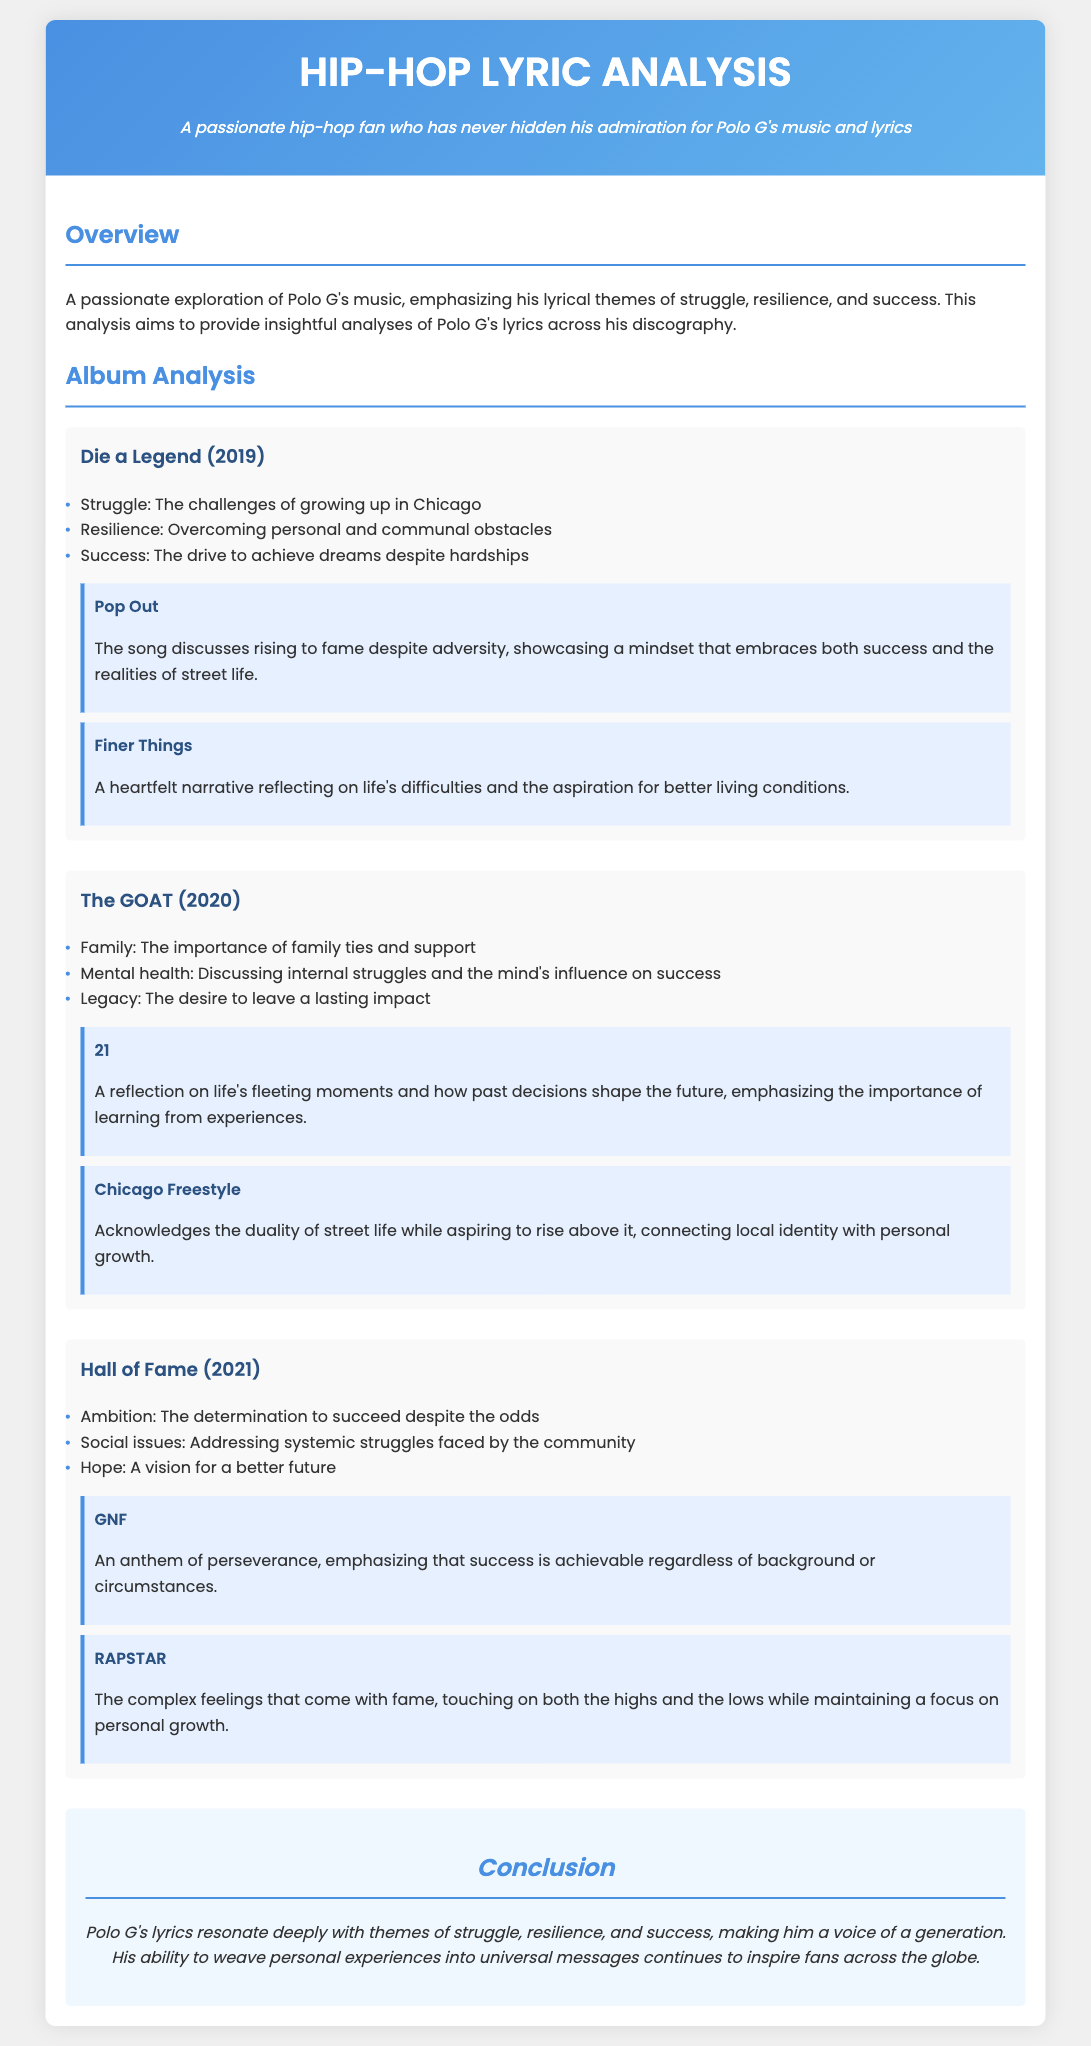What is the title of the resume? The title is prominently displayed at the top of the document, stating the focus on lyrical analysis of Polo G's work.
Answer: Hip-Hop Lyric Analysis What year was the album "Die a Legend" released? The album's release year is mentioned as part of its section heading in the document.
Answer: 2019 Name a key theme from "The GOAT" album. The key themes section lists important concepts related to each album, including family, mental health, and legacy for "The GOAT."
Answer: Family Which song from "Hall of Fame" emphasizes perseverance? The key songs listed under this album indicate which tracks emphasize particular themes, including perseverance.
Answer: GNF How many key themes are associated with the album "The GOAT"? The number of items listed under key themes for "The GOAT" indicates how many themes are discussed for that album.
Answer: 3 What is the concluding message of the resume? The conclusion section summarizes the overall impression of the lyrical themes present in Polo G's music.
Answer: Voice of a generation Which song discusses the importance of learning from experiences? The key songs listed under each album highlight specific messages, with one mentioning life’s fleeting moments and learning from decisions.
Answer: 21 What color is used in the header background? The document describes the color scheme, including the gradient background for the header section.
Answer: Gradient of blue What is the visual style of the document? The structure and style of the document highlight its design choices, making it visually appealing and organized.
Answer: Visually appealing format 